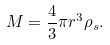Convert formula to latex. <formula><loc_0><loc_0><loc_500><loc_500>M = \frac { 4 } { 3 } \pi r ^ { 3 } \rho _ { s } .</formula> 